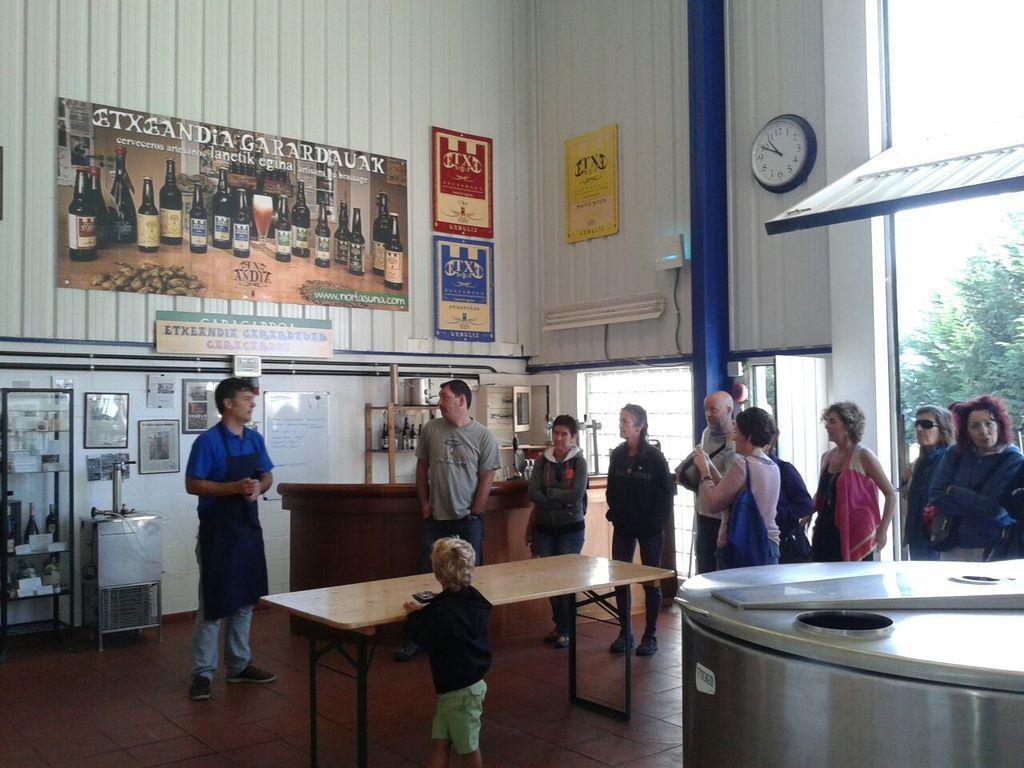How would you summarize this image in a sentence or two? In this picture i could see many persons standing inside a shop it seems like a beer shop. In the background i could see banners attached on white wall a clock to the right side of the wall and down there is a brown table and help desk to the right corner and out side there are trees. 